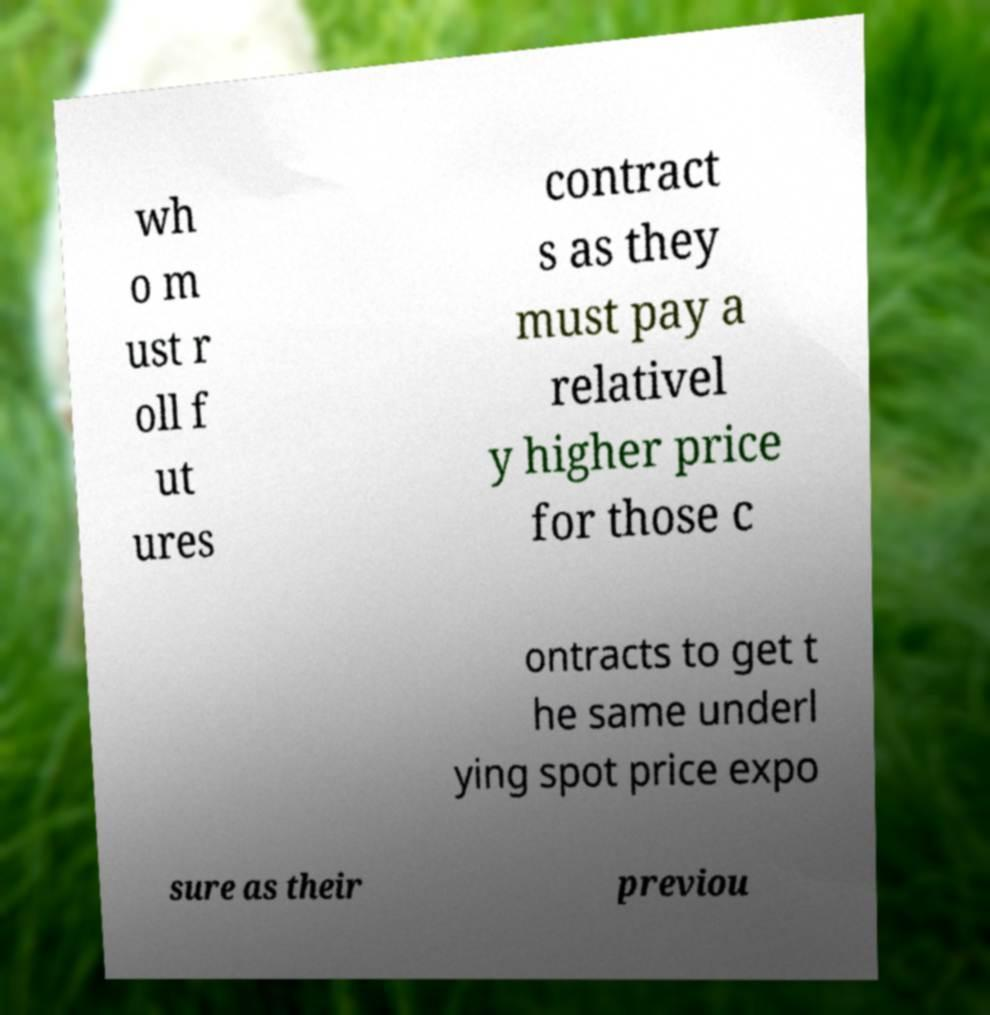Can you read and provide the text displayed in the image?This photo seems to have some interesting text. Can you extract and type it out for me? wh o m ust r oll f ut ures contract s as they must pay a relativel y higher price for those c ontracts to get t he same underl ying spot price expo sure as their previou 